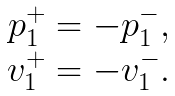Convert formula to latex. <formula><loc_0><loc_0><loc_500><loc_500>\begin{array} { c c c } p _ { 1 } ^ { + } = - p _ { 1 } ^ { - } , \\ v _ { 1 } ^ { + } = - v _ { 1 } ^ { - } . \end{array}</formula> 